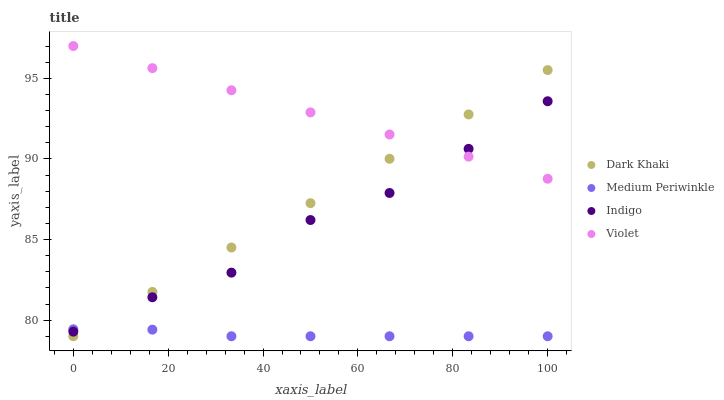Does Medium Periwinkle have the minimum area under the curve?
Answer yes or no. Yes. Does Violet have the maximum area under the curve?
Answer yes or no. Yes. Does Indigo have the minimum area under the curve?
Answer yes or no. No. Does Indigo have the maximum area under the curve?
Answer yes or no. No. Is Dark Khaki the smoothest?
Answer yes or no. Yes. Is Indigo the roughest?
Answer yes or no. Yes. Is Medium Periwinkle the smoothest?
Answer yes or no. No. Is Medium Periwinkle the roughest?
Answer yes or no. No. Does Dark Khaki have the lowest value?
Answer yes or no. Yes. Does Indigo have the lowest value?
Answer yes or no. No. Does Violet have the highest value?
Answer yes or no. Yes. Does Indigo have the highest value?
Answer yes or no. No. Is Medium Periwinkle less than Violet?
Answer yes or no. Yes. Is Violet greater than Medium Periwinkle?
Answer yes or no. Yes. Does Dark Khaki intersect Violet?
Answer yes or no. Yes. Is Dark Khaki less than Violet?
Answer yes or no. No. Is Dark Khaki greater than Violet?
Answer yes or no. No. Does Medium Periwinkle intersect Violet?
Answer yes or no. No. 